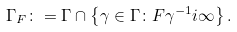Convert formula to latex. <formula><loc_0><loc_0><loc_500><loc_500>\Gamma _ { F } \colon = \Gamma \cap \left \{ \gamma \in \Gamma \colon F \gamma ^ { - 1 } i \infty \right \} .</formula> 